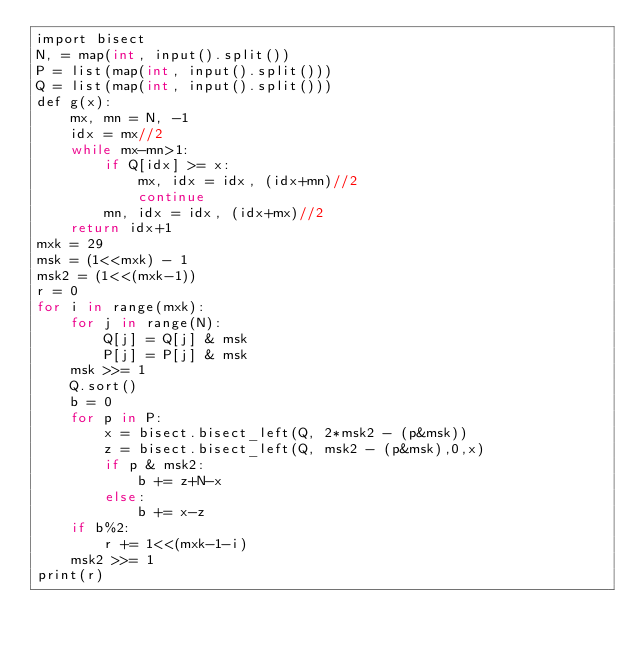<code> <loc_0><loc_0><loc_500><loc_500><_C#_>import bisect
N, = map(int, input().split())
P = list(map(int, input().split()))
Q = list(map(int, input().split()))
def g(x):
    mx, mn = N, -1
    idx = mx//2
    while mx-mn>1:
        if Q[idx] >= x:
            mx, idx = idx, (idx+mn)//2
            continue
        mn, idx = idx, (idx+mx)//2
    return idx+1
mxk = 29
msk = (1<<mxk) - 1
msk2 = (1<<(mxk-1))
r = 0
for i in range(mxk):
    for j in range(N):
        Q[j] = Q[j] & msk
        P[j] = P[j] & msk
    msk >>= 1
    Q.sort()
    b = 0
    for p in P:
        x = bisect.bisect_left(Q, 2*msk2 - (p&msk))
        z = bisect.bisect_left(Q, msk2 - (p&msk),0,x)
        if p & msk2:
            b += z+N-x
        else:
            b += x-z
    if b%2:
        r += 1<<(mxk-1-i)
    msk2 >>= 1
print(r)
</code> 